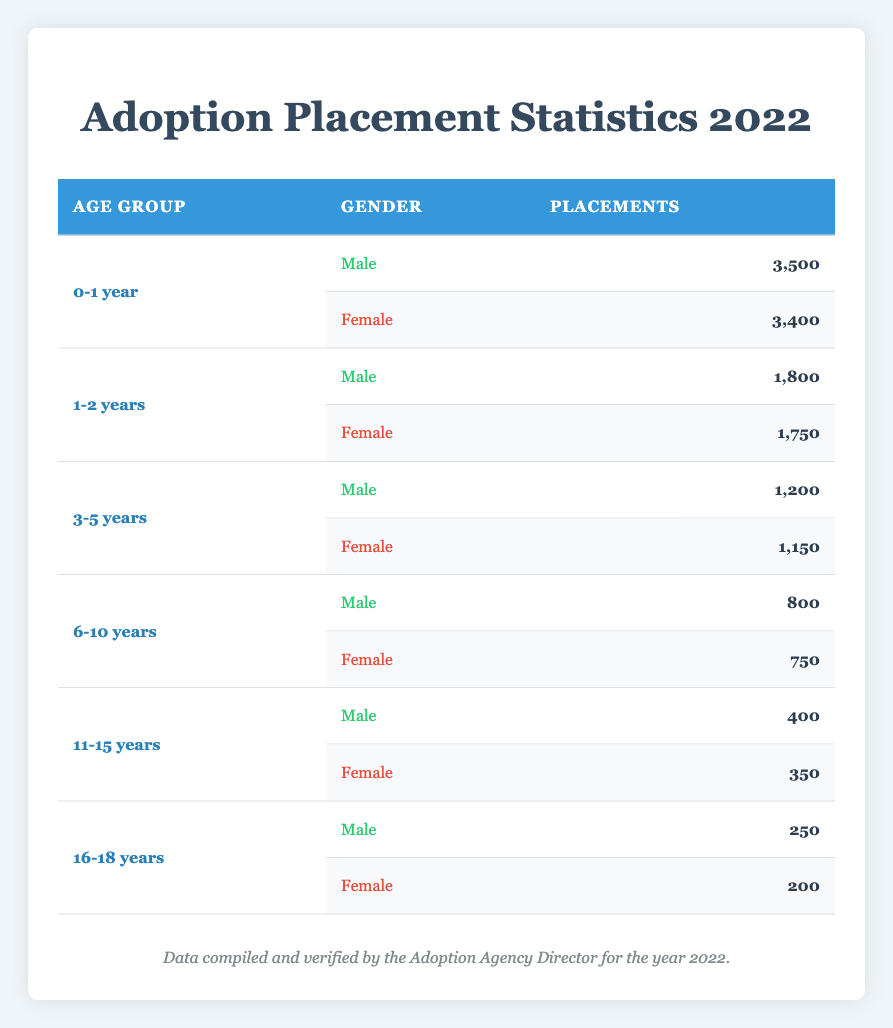What is the total number of placements for children aged 0-1 year? According to the table, the placements for children aged 0-1 year are 3,500 for males and 3,400 for females. Adding these figures gives us 3,500 + 3,400 = 6,900.
Answer: 6,900 How many more male children than female children were placed in the age group of 1-2 years? In the 1-2 years age group, there were 1,800 male placements and 1,750 female placements. The difference is calculated by subtracting the number of female placements from the number of male placements: 1,800 - 1,750 = 50.
Answer: 50 Was there a higher number of placements for males or females in the 3-5 years age group? For the age group of 3-5 years, there were 1,200 male placements compared to 1,150 female placements. So, males had a higher number of placements because 1,200 is greater than 1,150.
Answer: Yes, more males were placed What is the total number of placements for children in the age group of 11-15 years? The table shows that there were 400 males and 350 females in the 11-15 years age group. Summing these gives us 400 + 350 = 750 placements in total.
Answer: 750 What is the average number of placements for females across all age groups? To find the average, we first sum the placements for females: 3,400 (0-1 year) + 1,750 (1-2 years) + 1,150 (3-5 years) + 750 (6-10 years) + 350 (11-15 years) + 200 (16-18 years) = 7,600. Since there are 6 age groups, we divide the total by 6: 7,600 / 6 = approximately 1,267.
Answer: 1,267 Are there more total placements for children aged 0-1 year than for children aged 16-18 years? The total placements for children aged 0-1 year is 6,900 (3,500 males + 3,400 females), while for those aged 16-18 years, the placements are 450 (250 males + 200 females). Since 6,900 is greater than 450, there are indeed more placements for the younger age group.
Answer: Yes, there are more placements for 0-1 year 